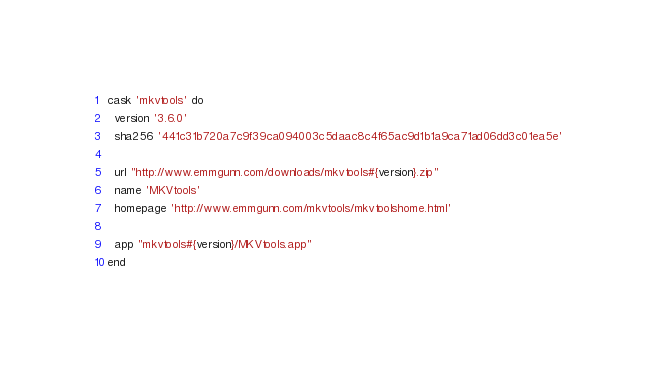<code> <loc_0><loc_0><loc_500><loc_500><_Ruby_>cask 'mkvtools' do
  version '3.6.0'
  sha256 '441c31b720a7c9f39ca094003c5daac8c4f65ac9d1b1a9ca71ad06dd3c01ea5e'

  url "http://www.emmgunn.com/downloads/mkvtools#{version}.zip"
  name 'MKVtools'
  homepage 'http://www.emmgunn.com/mkvtools/mkvtoolshome.html'

  app "mkvtools#{version}/MKVtools.app"
end
</code> 